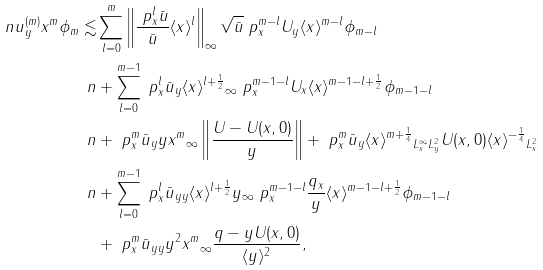<formula> <loc_0><loc_0><loc_500><loc_500>\ n \| u _ { y } ^ { ( m ) } x ^ { m } \phi _ { m } \| \lesssim & \sum _ { l = 0 } ^ { m } \left \| \frac { \ p _ { x } ^ { l } \bar { u } } { \bar { u } } \langle x \rangle ^ { l } \right \| _ { \infty } \| \sqrt { \bar { u } } \ p _ { x } ^ { m - l } U _ { y } \langle x \rangle ^ { m - l } \phi _ { m - l } \| \\ \ n & + \sum _ { l = 0 } ^ { m - 1 } \| \ p _ { x } ^ { l } \bar { u } _ { y } \langle x \rangle ^ { l + \frac { 1 } { 2 } } \| _ { \infty } \| \ p _ { x } ^ { m - 1 - l } U _ { x } \langle x \rangle ^ { m - 1 - l + \frac { 1 } { 2 } } \phi _ { m - 1 - l } \| \\ \ n & + \| \ p _ { x } ^ { m } \bar { u } _ { y } y x ^ { m } \| _ { \infty } \left \| \frac { U - U ( x , 0 ) } { y } \right \| + \| \ p _ { x } ^ { m } \bar { u } _ { y } \langle x \rangle ^ { m + \frac { 1 } { 4 } } \| _ { L ^ { \infty } _ { x } L ^ { 2 } _ { y } } \| U ( x , 0 ) \langle x \rangle ^ { - \frac { 1 } { 4 } } \| _ { L ^ { 2 } _ { x } } \\ \ n & + \sum _ { l = 0 } ^ { m - 1 } \| \ p _ { x } ^ { l } \bar { u } _ { y y } \langle x \rangle ^ { l + \frac { 1 } { 2 } } y \| _ { \infty } \| \ p _ { x } ^ { m - 1 - l } \frac { q _ { x } } { y } \langle x \rangle ^ { m - 1 - l + \frac { 1 } { 2 } } \phi _ { m - 1 - l } \| \\ & + \| \ p _ { x } ^ { m } \bar { u } _ { y y } y ^ { 2 } x ^ { m } \| _ { \infty } \| \frac { q - y U ( x , 0 ) } { \langle y \rangle ^ { 2 } } \| ,</formula> 